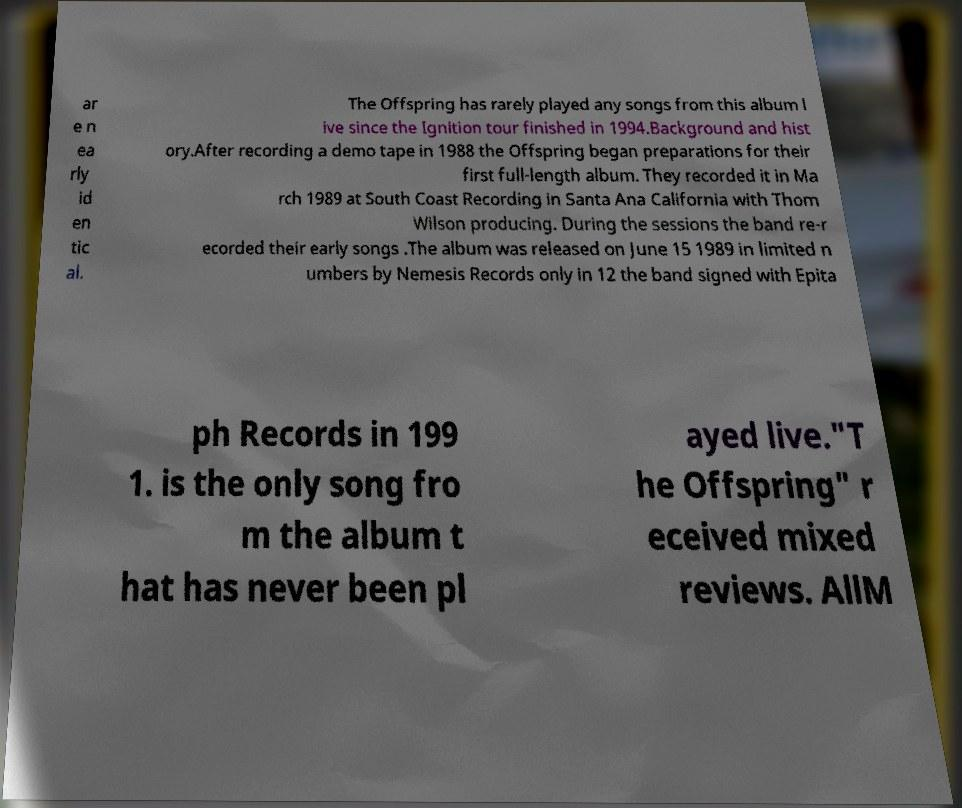There's text embedded in this image that I need extracted. Can you transcribe it verbatim? ar e n ea rly id en tic al. The Offspring has rarely played any songs from this album l ive since the Ignition tour finished in 1994.Background and hist ory.After recording a demo tape in 1988 the Offspring began preparations for their first full-length album. They recorded it in Ma rch 1989 at South Coast Recording in Santa Ana California with Thom Wilson producing. During the sessions the band re-r ecorded their early songs .The album was released on June 15 1989 in limited n umbers by Nemesis Records only in 12 the band signed with Epita ph Records in 199 1. is the only song fro m the album t hat has never been pl ayed live."T he Offspring" r eceived mixed reviews. AllM 